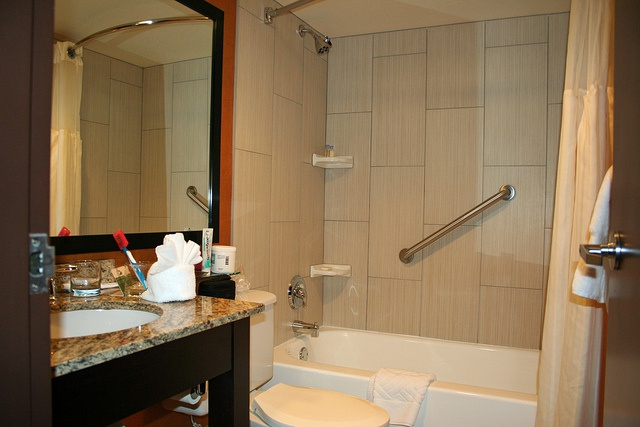Describe the objects in this image and their specific colors. I can see toilet in black and tan tones, sink in black, lightgray, and darkgray tones, cup in black, maroon, and brown tones, cup in black, maroon, gray, and olive tones, and toothbrush in black, red, brown, darkgray, and beige tones in this image. 